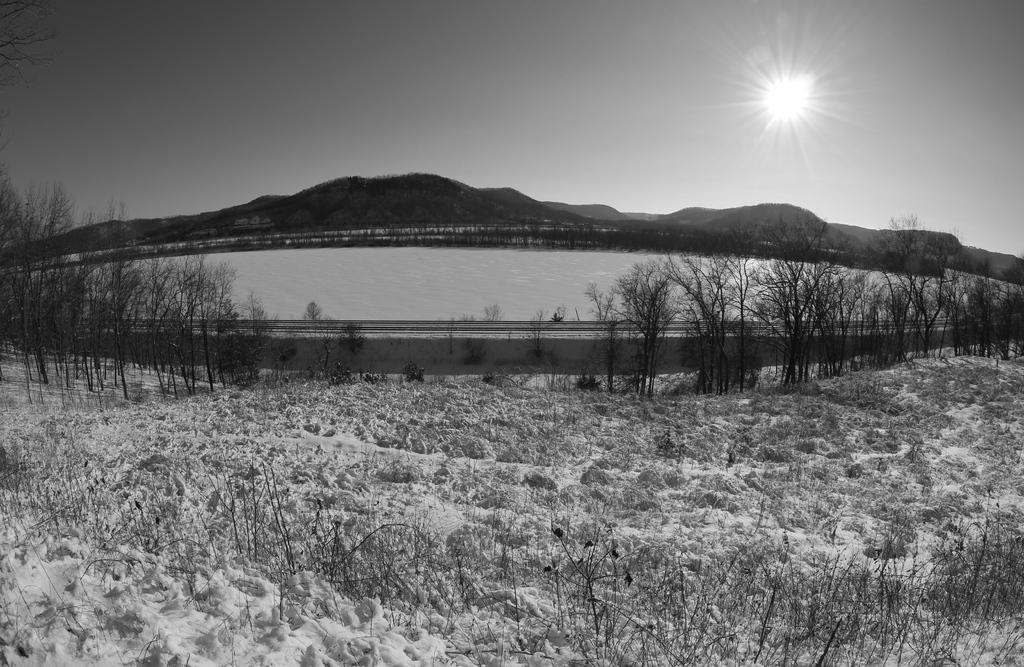How would you summarize this image in a sentence or two? In this picture there is a black and white photograph of river water. Behind there are some dry trees and mountains. Above there is a clear sky. 